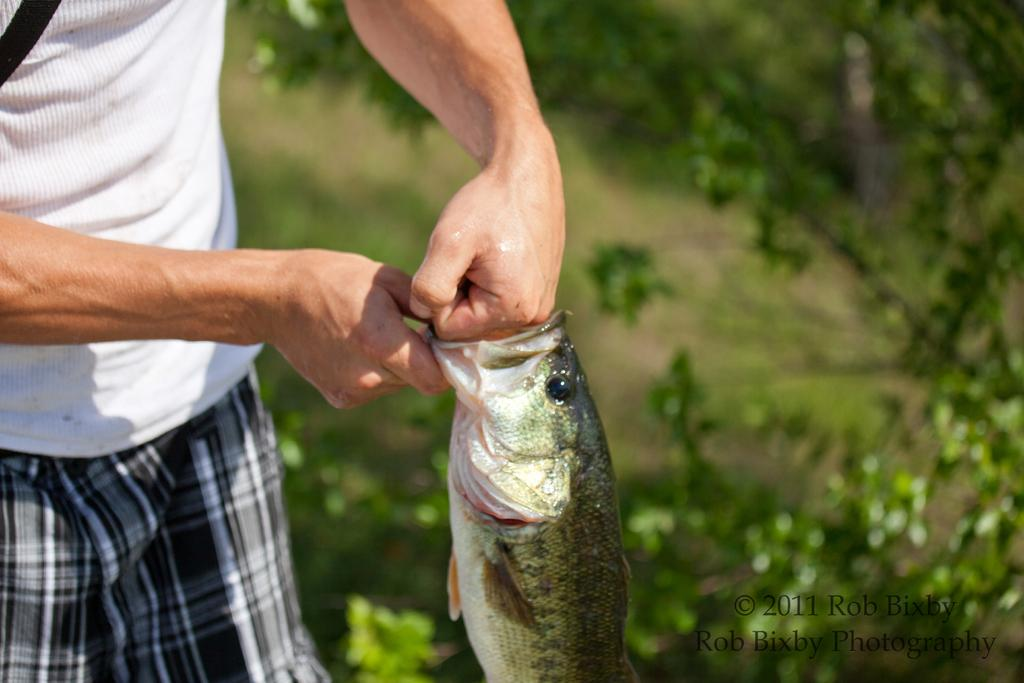What is the person in the image doing? The person is standing in the image and holding a fish. What can be seen in the background of the image? There are trees with branches and leaves in the background of the image. Is there any indication of the image's origin or ownership? Yes, there is a watermark on the image. How does the wind affect the person's hair in the image? There is no wind present in the image, so it cannot affect the person's hair. 